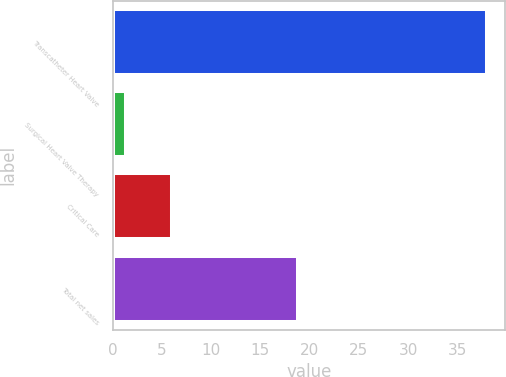<chart> <loc_0><loc_0><loc_500><loc_500><bar_chart><fcel>Transcatheter Heart Valve<fcel>Surgical Heart Valve Therapy<fcel>Critical Care<fcel>Total net sales<nl><fcel>38<fcel>1.3<fcel>6<fcel>18.8<nl></chart> 